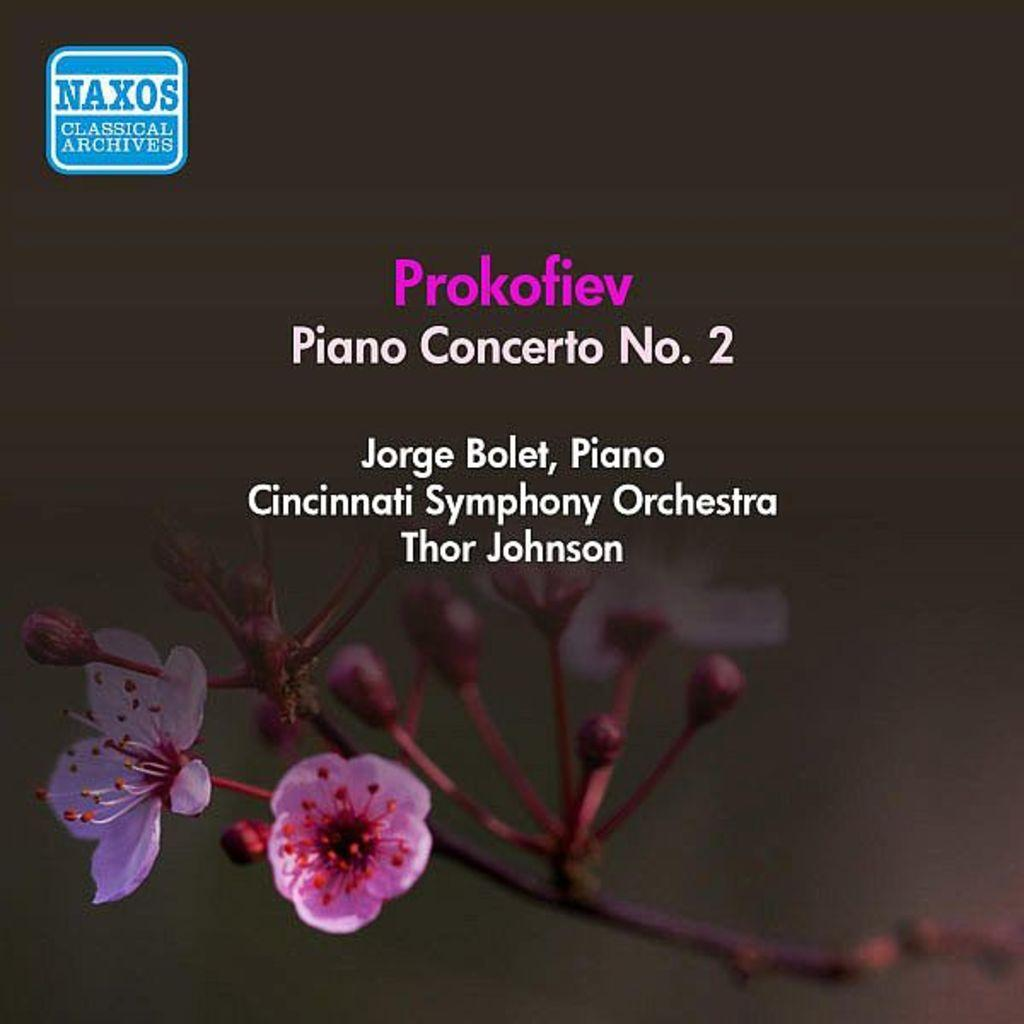<image>
Render a clear and concise summary of the photo. A cover for music by Jorge Bolet on piano has flowers on the bottom. 